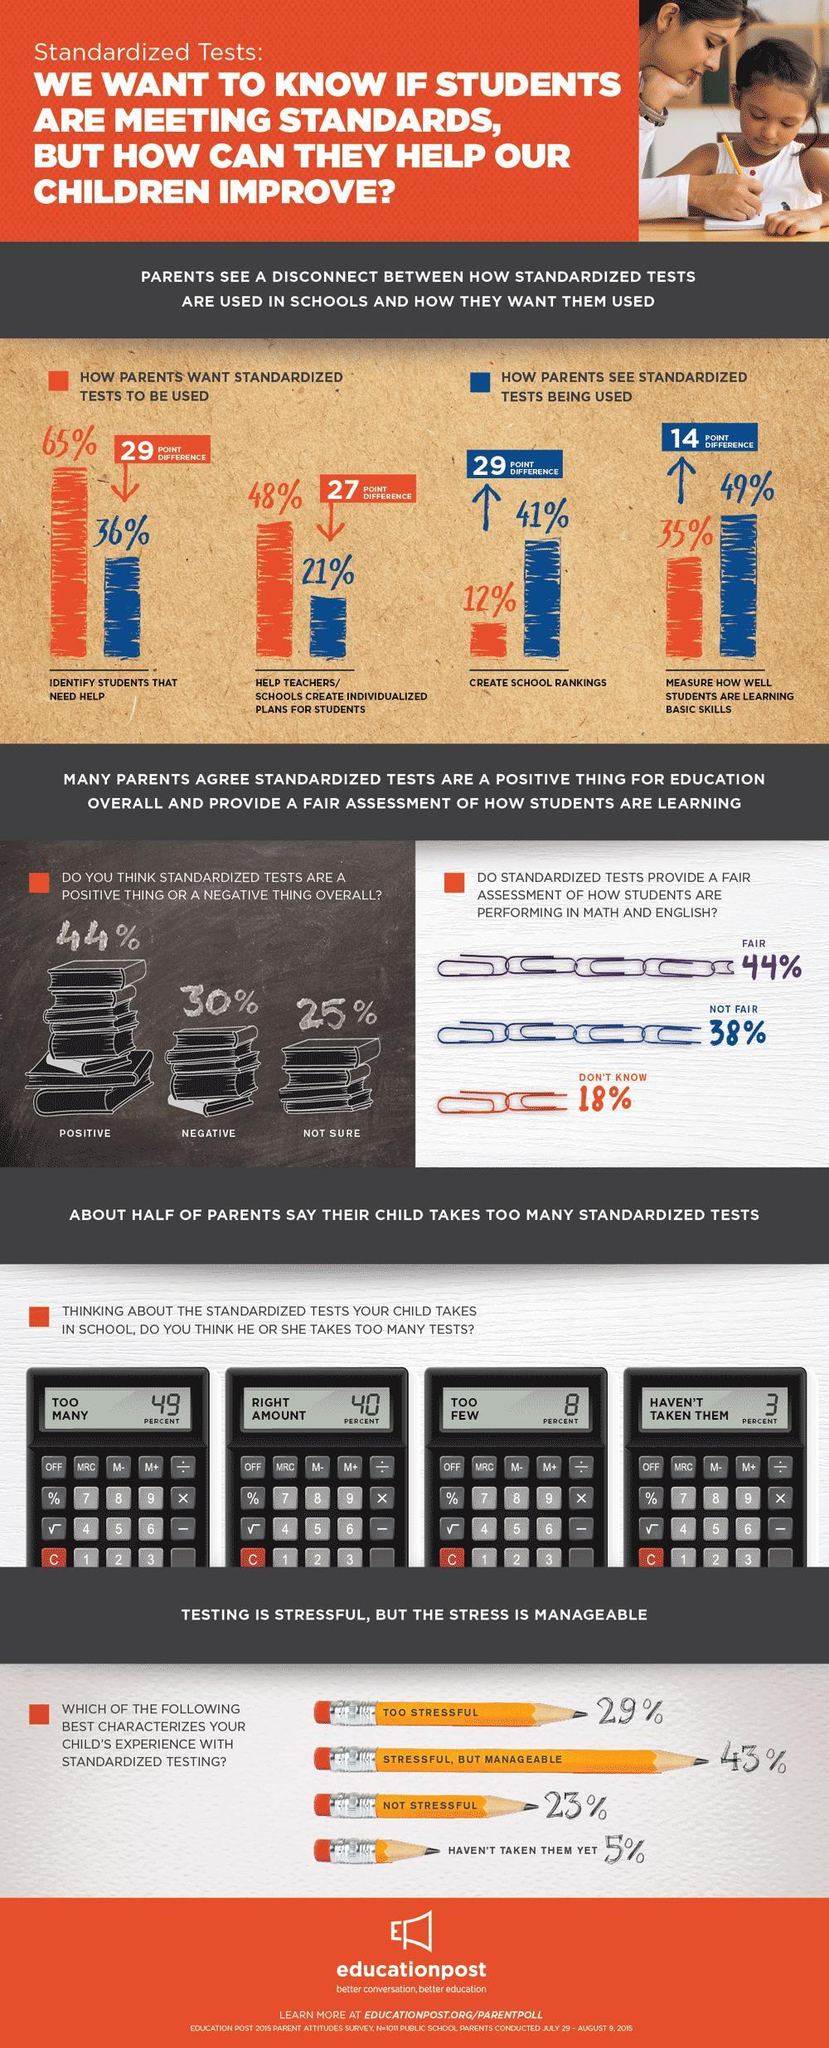What do 49% of parents feel about the number of tests taken?
Answer the question with a short phrase. too many How many of the parents think that standardized tests are a negative thing? 30% What is the opinion of 40% of the parents regarding the number of tests taken? right amount How many of the parents want tests to be used to identify students needing help? 65% what percent of parents want standardized tests used to create school rankings? 12% What percent of parents think that standardized tests are a positive thing? 44% How many of the parents feel that too few tests are taken? 8 percent How many of the parents see that tests measure how well students are learning? 49% 